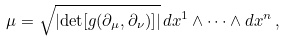Convert formula to latex. <formula><loc_0><loc_0><loc_500><loc_500>\mu = \sqrt { \left | \det [ g ( \partial _ { \mu } , \partial _ { \nu } ) ] \right | } \, d x ^ { 1 } \wedge \cdots \wedge d x ^ { n } \, ,</formula> 